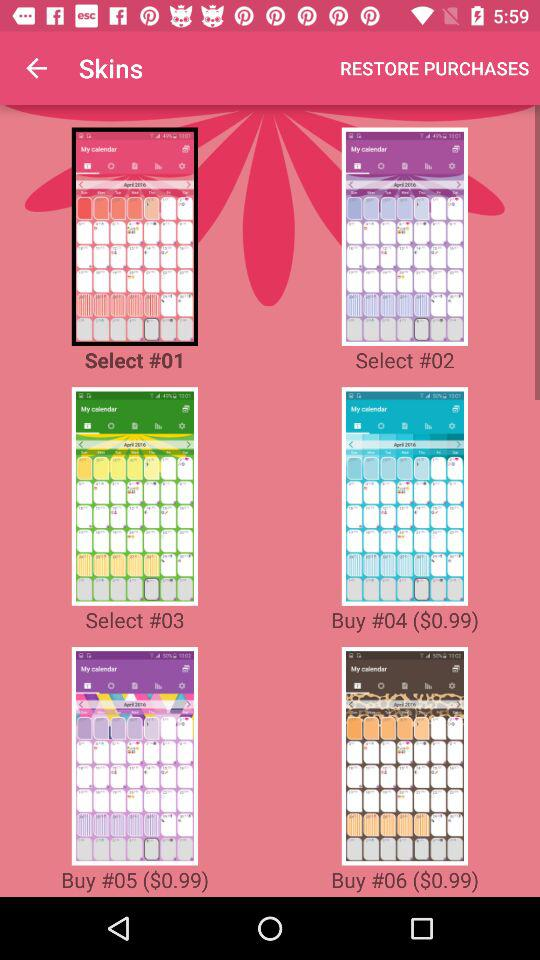How many skins are available for purchase?
Answer the question using a single word or phrase. 6 